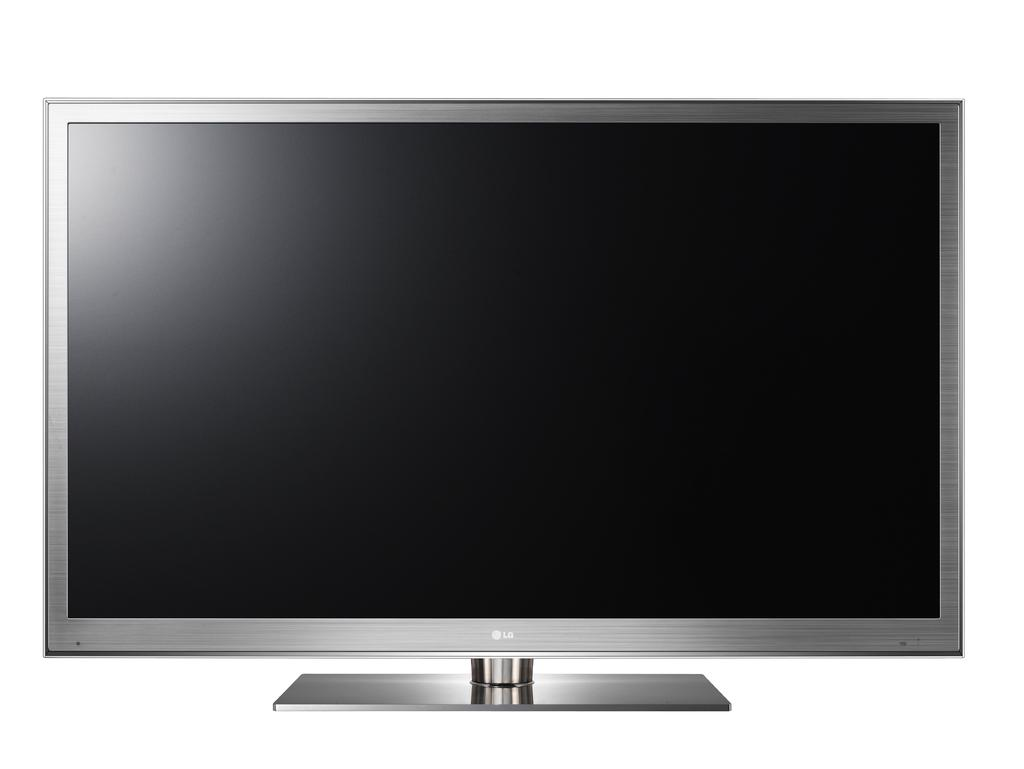What is the main object in the image? There is a television in the image. What type of flavor can be tasted in the clocks shown on the television in the image? There are no clocks or any reference to flavors in the image; it only features a television. 